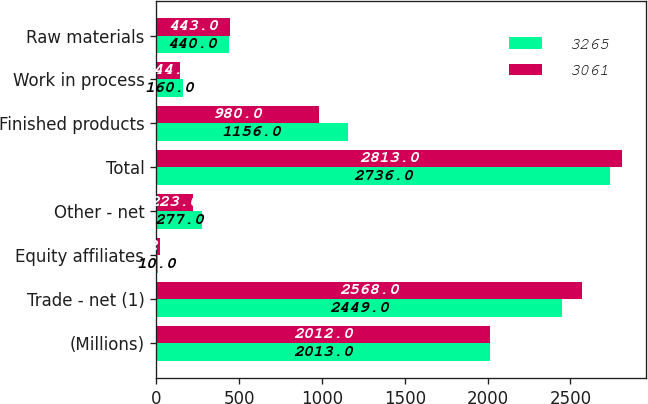Convert chart to OTSL. <chart><loc_0><loc_0><loc_500><loc_500><stacked_bar_chart><ecel><fcel>(Millions)<fcel>Trade - net (1)<fcel>Equity affiliates<fcel>Other - net<fcel>Total<fcel>Finished products<fcel>Work in process<fcel>Raw materials<nl><fcel>3265<fcel>2013<fcel>2449<fcel>10<fcel>277<fcel>2736<fcel>1156<fcel>160<fcel>440<nl><fcel>3061<fcel>2012<fcel>2568<fcel>22<fcel>223<fcel>2813<fcel>980<fcel>144<fcel>443<nl></chart> 